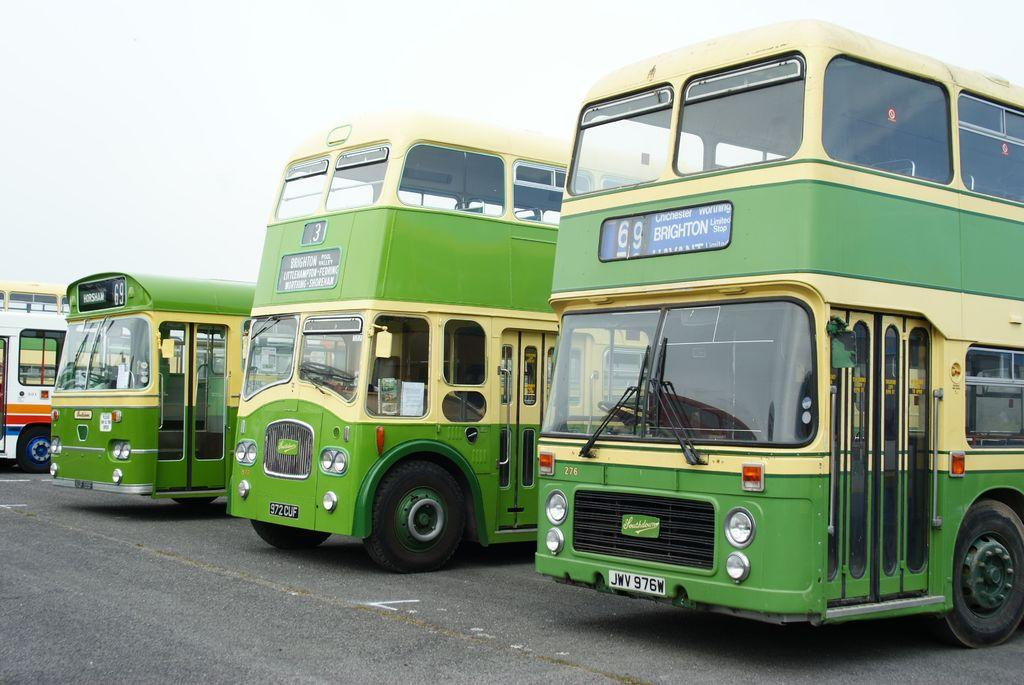Provide a one-sentence caption for the provided image. A green and yellow bus with 69 Brighton on it. 